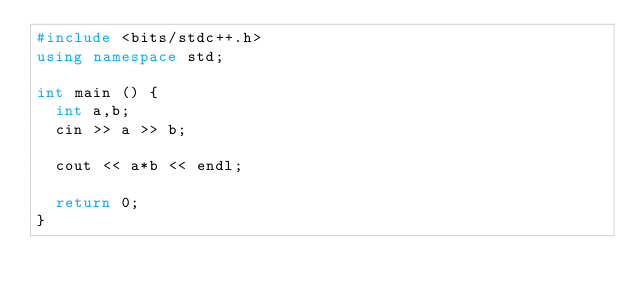Convert code to text. <code><loc_0><loc_0><loc_500><loc_500><_C++_>#include <bits/stdc++.h>
using namespace std;

int main () {
  int a,b;
  cin >> a >> b;

  cout << a*b << endl;
  
  return 0;
}
</code> 